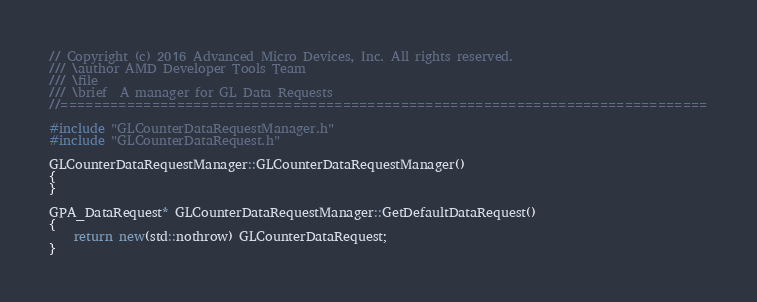<code> <loc_0><loc_0><loc_500><loc_500><_C++_>// Copyright (c) 2016 Advanced Micro Devices, Inc. All rights reserved.
/// \author AMD Developer Tools Team
/// \file
/// \brief  A manager for GL Data Requests
//==============================================================================

#include "GLCounterDataRequestManager.h"
#include "GLCounterDataRequest.h"

GLCounterDataRequestManager::GLCounterDataRequestManager()
{
}

GPA_DataRequest* GLCounterDataRequestManager::GetDefaultDataRequest()
{
    return new(std::nothrow) GLCounterDataRequest;
}
</code> 